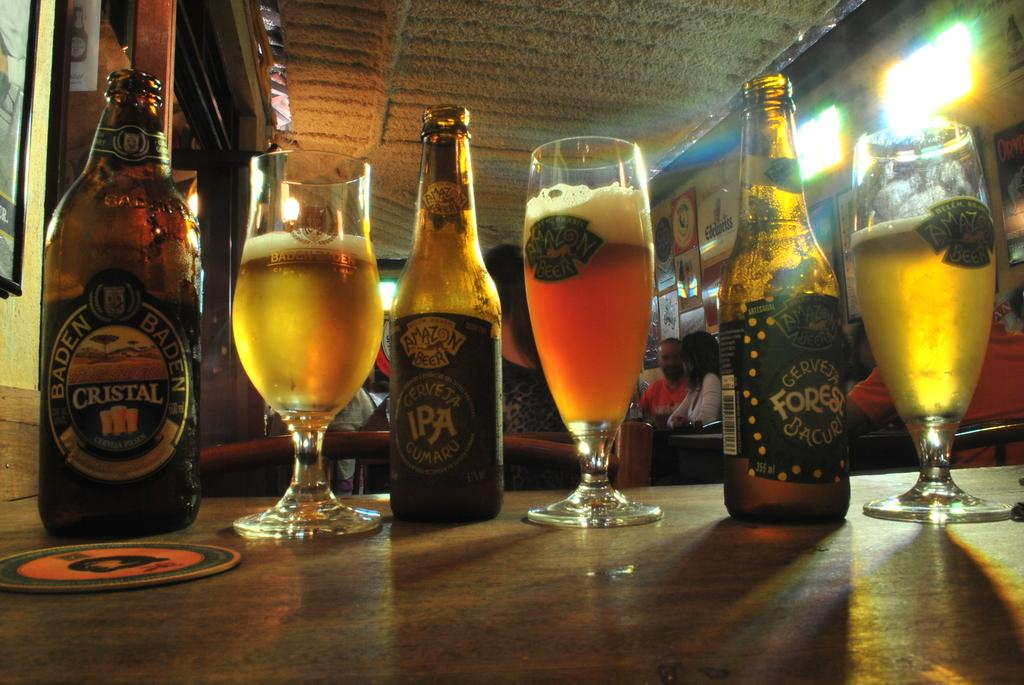<image>
Summarize the visual content of the image. A bottle of Cristal on a table with a bottle of Cerveja IPA 